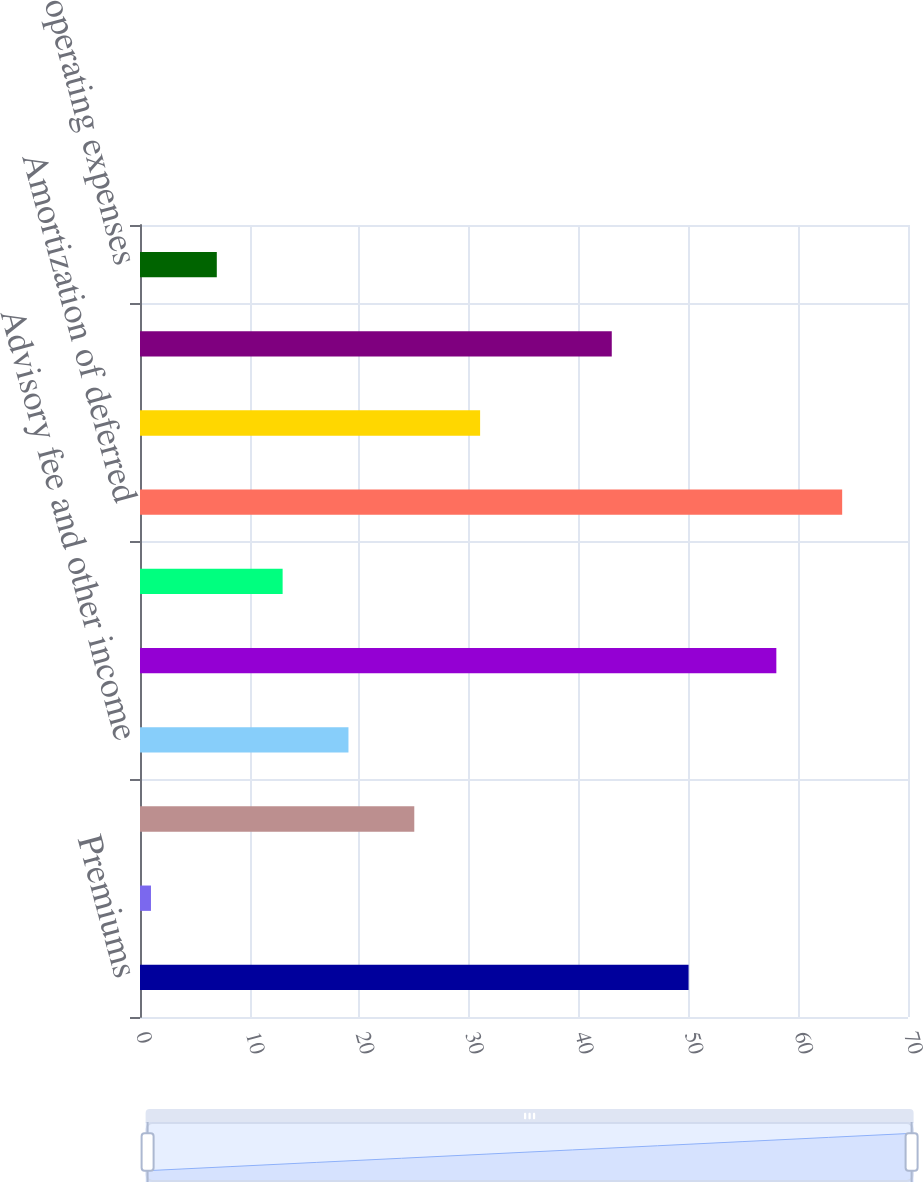Convert chart to OTSL. <chart><loc_0><loc_0><loc_500><loc_500><bar_chart><fcel>Premiums<fcel>Policy fees<fcel>Net investment income<fcel>Advisory fee and other income<fcel>Policyholder benefits and<fcel>Interest credited to<fcel>Amortization of deferred<fcel>Non deferrable insurance<fcel>Advisory fee expenses<fcel>General operating expenses<nl><fcel>50<fcel>1<fcel>25<fcel>19<fcel>58<fcel>13<fcel>64<fcel>31<fcel>43<fcel>7<nl></chart> 